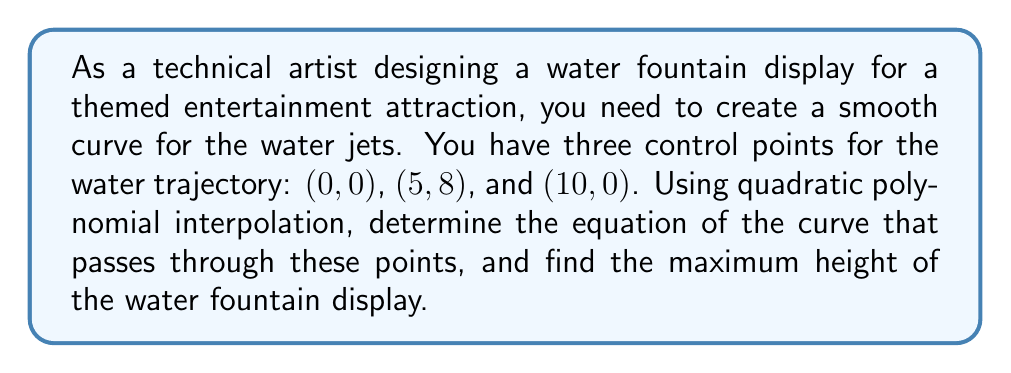Show me your answer to this math problem. To solve this problem, we'll follow these steps:

1. Set up the quadratic polynomial equation:
   $$f(x) = ax^2 + bx + c$$

2. Use the three given points to create a system of equations:
   $$f(0) = 0: c = 0$$
   $$f(5) = 8: 25a + 5b = 8$$
   $$f(10) = 0: 100a + 10b = 0$$

3. Solve the system of equations:
   From the third equation: $10a + b = 0$, so $b = -10a$
   Substituting into the second equation:
   $$25a + 5(-10a) = 8$$
   $$25a - 50a = 8$$
   $$-25a = 8$$
   $$a = -\frac{8}{25} = -0.32$$

   Now we can find $b$:
   $$b = -10a = -10(-0.32) = 3.2$$

4. Write the equation of the curve:
   $$f(x) = -0.32x^2 + 3.2x$$

5. To find the maximum height, we need to find the vertex of the parabola:
   The x-coordinate of the vertex is given by $x = -\frac{b}{2a}$:
   $$x = -\frac{3.2}{2(-0.32)} = 5$$

6. Calculate the maximum height by plugging $x = 5$ into the equation:
   $$f(5) = -0.32(5)^2 + 3.2(5) = -8 + 16 = 8$$

Therefore, the maximum height of the water fountain display is 8 units.
Answer: The equation of the curve is $f(x) = -0.32x^2 + 3.2x$, and the maximum height of the water fountain display is 8 units. 